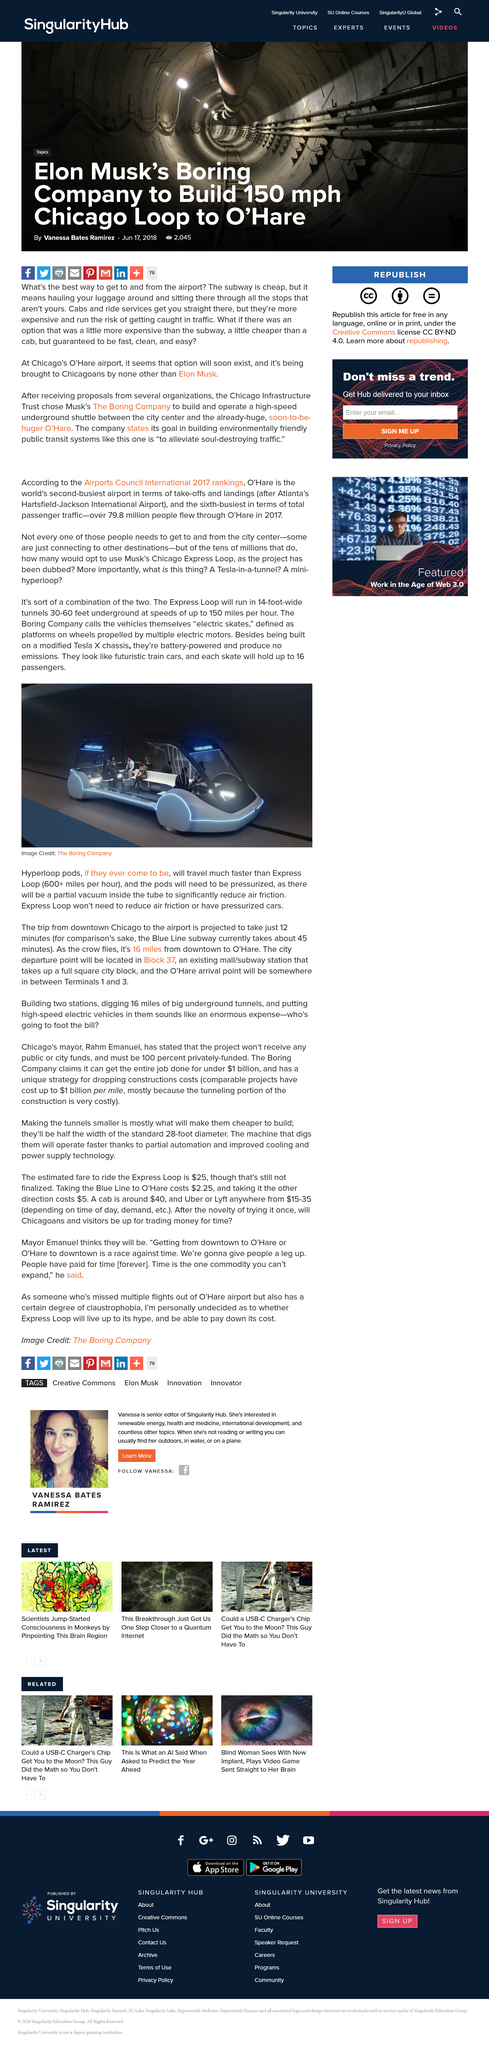Identify some key points in this picture. According to the Airports Council International's 2017 rankings, O'Hare Airport is the world's second-busiest airport in terms of take-offs and landings and the sixth-busiest in terms of total passenger traffic. Annually, over 79.8 million people flew from O'Hare International Airport. The image obtained from The Boring Company depicts an electric skate, which can be observed in the foreground. 